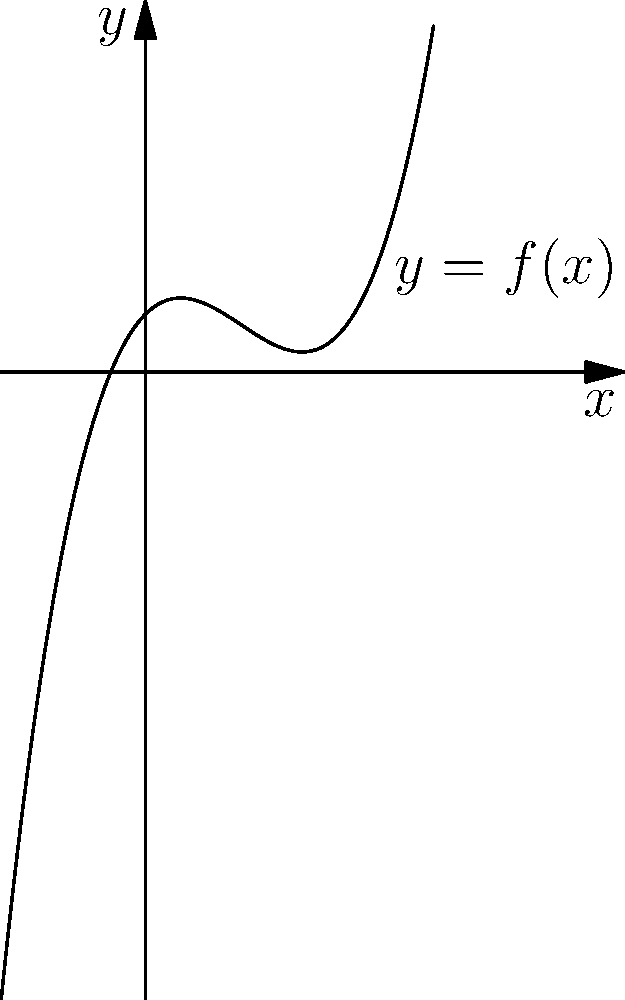Given the graph of a polynomial function $f(x)$, determine the behavior of the function as $x$ approaches positive infinity. How would this information help in designing an algorithm for data extraction that scales with increasing input size? To determine the behavior of the polynomial function as $x$ approaches positive infinity, we need to analyze the graph:

1. Observe the rightmost part of the graph: it's increasing and curving upward.
2. This upward curve indicates that the function is growing faster than linear growth.
3. The shape suggests a polynomial of degree 3 or higher (odd degree).
4. As $x$ increases, $y$ values are increasing at an increasing rate.
5. This behavior implies that $\lim_{x \to +\infty} f(x) = +\infty$.

For a software developer working with APIs and data extraction:

1. Understanding this behavior helps in predicting how algorithms scale with input size.
2. The polynomial growth suggests that processing time or resource usage will increase rapidly as data size grows.
3. This insight is crucial for designing efficient data extraction processes that can handle large datasets.
4. It indicates a need for optimization techniques or distributed processing for large-scale data operations.
5. When developing APIs, this understanding helps in setting appropriate rate limits or pagination strategies for data retrieval.
Answer: The function grows towards positive infinity as $x$ approaches positive infinity, indicating polynomial time complexity which informs scalability considerations in API design and data extraction processes. 